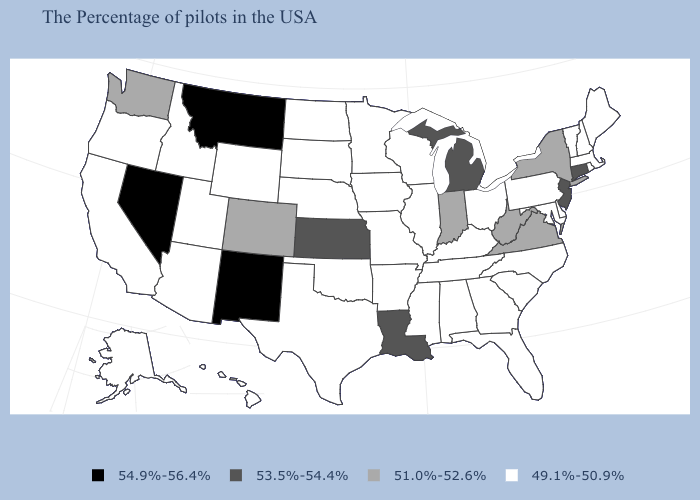Name the states that have a value in the range 49.1%-50.9%?
Answer briefly. Maine, Massachusetts, Rhode Island, New Hampshire, Vermont, Delaware, Maryland, Pennsylvania, North Carolina, South Carolina, Ohio, Florida, Georgia, Kentucky, Alabama, Tennessee, Wisconsin, Illinois, Mississippi, Missouri, Arkansas, Minnesota, Iowa, Nebraska, Oklahoma, Texas, South Dakota, North Dakota, Wyoming, Utah, Arizona, Idaho, California, Oregon, Alaska, Hawaii. What is the highest value in the Northeast ?
Write a very short answer. 53.5%-54.4%. Among the states that border Rhode Island , which have the lowest value?
Short answer required. Massachusetts. What is the highest value in the USA?
Give a very brief answer. 54.9%-56.4%. Name the states that have a value in the range 51.0%-52.6%?
Concise answer only. New York, Virginia, West Virginia, Indiana, Colorado, Washington. What is the lowest value in the USA?
Answer briefly. 49.1%-50.9%. Does California have the same value as Idaho?
Answer briefly. Yes. Does Maine have a lower value than Montana?
Answer briefly. Yes. Name the states that have a value in the range 54.9%-56.4%?
Concise answer only. New Mexico, Montana, Nevada. Does Ohio have the same value as New Hampshire?
Concise answer only. Yes. What is the value of West Virginia?
Give a very brief answer. 51.0%-52.6%. What is the highest value in states that border Missouri?
Write a very short answer. 53.5%-54.4%. Name the states that have a value in the range 51.0%-52.6%?
Be succinct. New York, Virginia, West Virginia, Indiana, Colorado, Washington. Name the states that have a value in the range 51.0%-52.6%?
Quick response, please. New York, Virginia, West Virginia, Indiana, Colorado, Washington. Does the first symbol in the legend represent the smallest category?
Write a very short answer. No. 